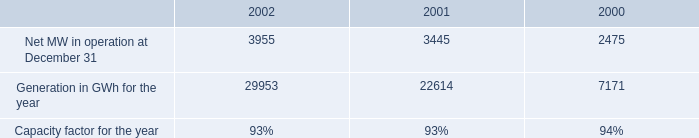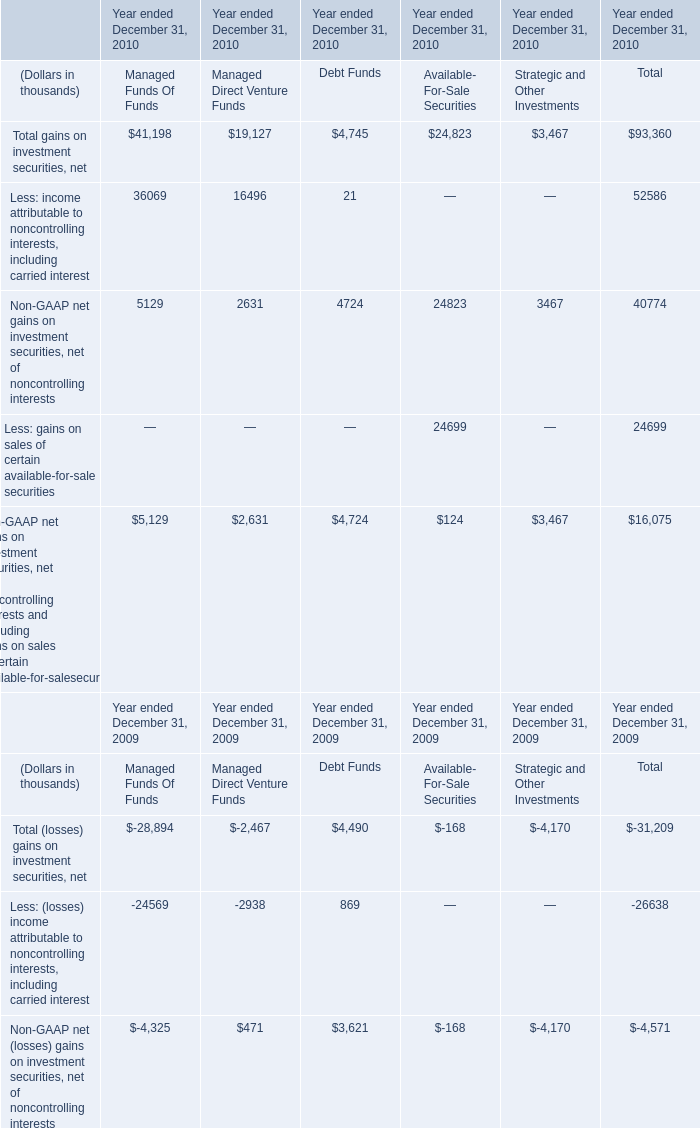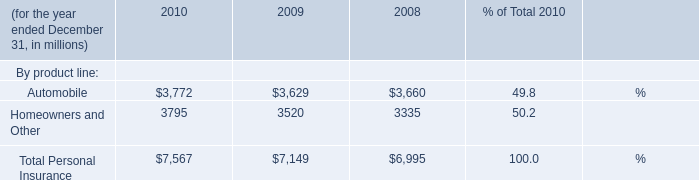what was the percent of the increase in non-utility nuclear earnings in 2002 
Computations: ((201 - 128) / 128)
Answer: 0.57031. what is the percent change in operating revenues from 2001 to 2002? 
Computations: (((1.2 * 1000) - 411.0) / 411.0)
Answer: 1.91971. 